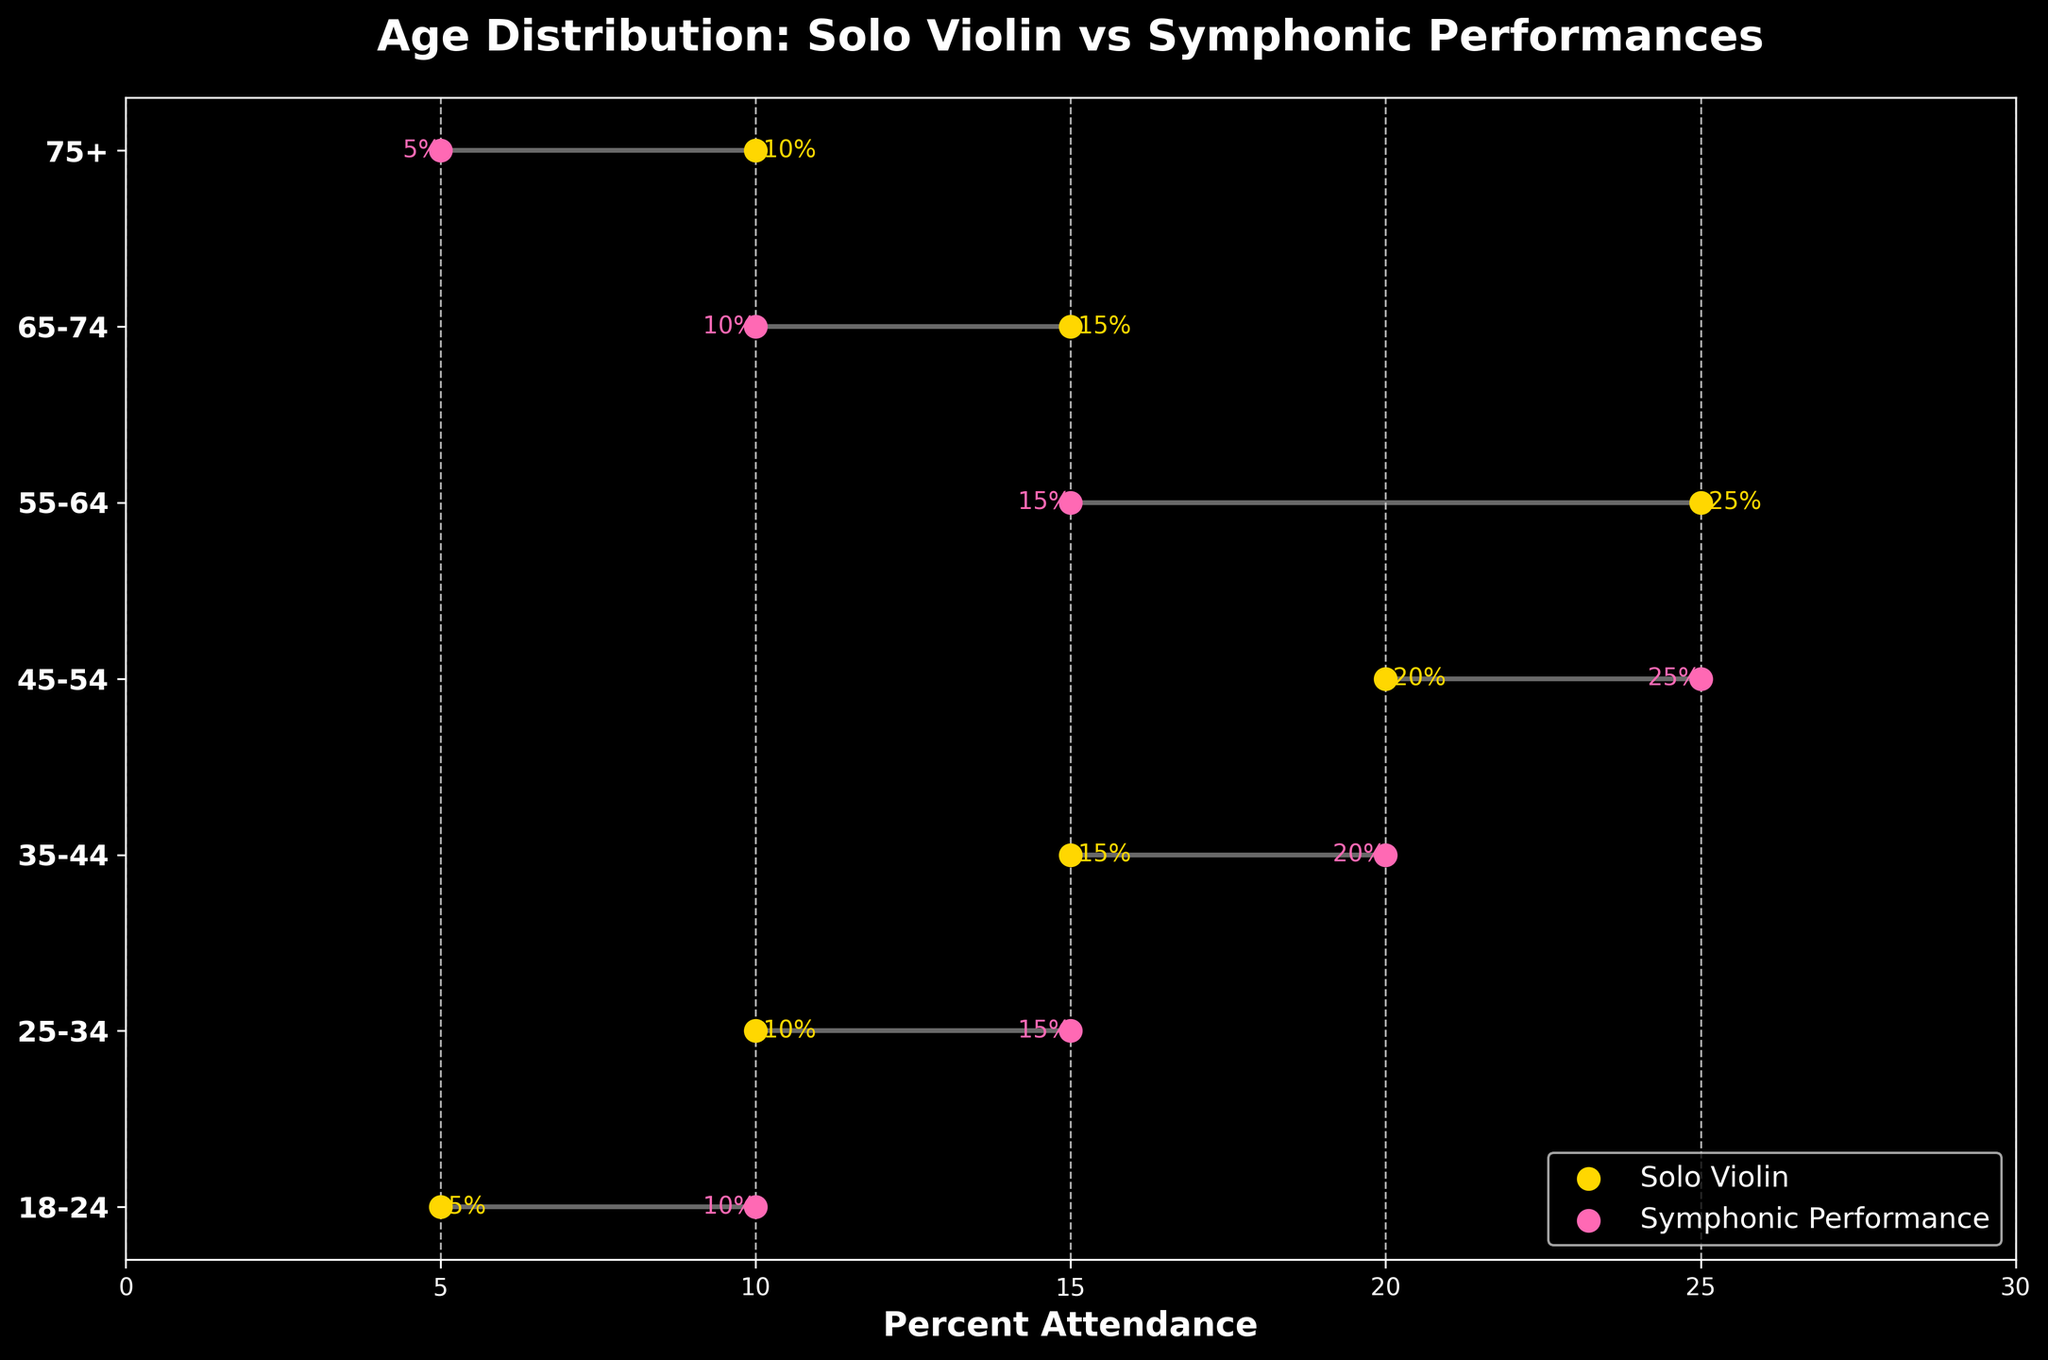What is the title of the figure? The title of the figure is prominently placed at the top and can be easily read.
Answer: Age Distribution: Solo Violin vs Symphonic Performances Which age group has the highest attendance for Solo Violin concerts? By examining the yellow dots representing Solo Violin attendance, we can see that the 55-64 age group has the highest attendance.
Answer: 55-64 Which age group has the lowest attendance for Symphonic Performances? By examining the pink dots representing Symphonic Performance attendance, we observe that the 75+ age group has the lowest attendance.
Answer: 75+ What is the color used to represent Solo Violin attendance? The plot uses different colors for each concert type: Solo Violin is represented by yellow dots.
Answer: Yellow What is the difference in attendance percentage between Solo Violin and Symphonic Performances for the 18-24 age group? For the 18-24 age group, Solo Violin attendance is 5%, and Symphonic Performance attendance is 10%. The difference is 10% - 5% = 5%.
Answer: 5% In which age group is the attendance for Solo Violin higher than for Symphonic Performances? By comparing the yellow and pink dot positions, we see that the 55-64 age group has a higher Solo Violin attendance (25%) compared to Symphonic Performances (15%).
Answer: 55-64 Identify an age group where the attendance for Symphonic Performances is double that of Solo Violin. For the 18-24 age group, Solo Violin attendance is 5%, while Symphonic Performance attendance is 10%, which is twice as much.
Answer: 18-24 Which age group shows the smallest difference in attendance between Solo Violin and Symphonic Performances? The 35-44 and 45-54 age groups both show a difference of 5% between the two concert types. This is the smallest difference observed.
Answer: 35-44, 45-54 For the age group 25-34, what is the combined attendance percentage for both concert types? Sum up the attendance percentages for both Solo Violin (10%) and Symphonic Performances (15%) for the 25-34 age group: 10% + 15% = 25%.
Answer: 25% What is the average attendance percentage for Symphonic Performances across all age groups? Obtain the Symphonic Performance attendance values (10, 15, 20, 25, 15, 10, 5), sum them (10 + 15 + 20 + 25 + 15 + 10 + 5 = 100), and divide by the number of age groups (7): 100 / 7 ≈ 14.29%.
Answer: 14.29% 